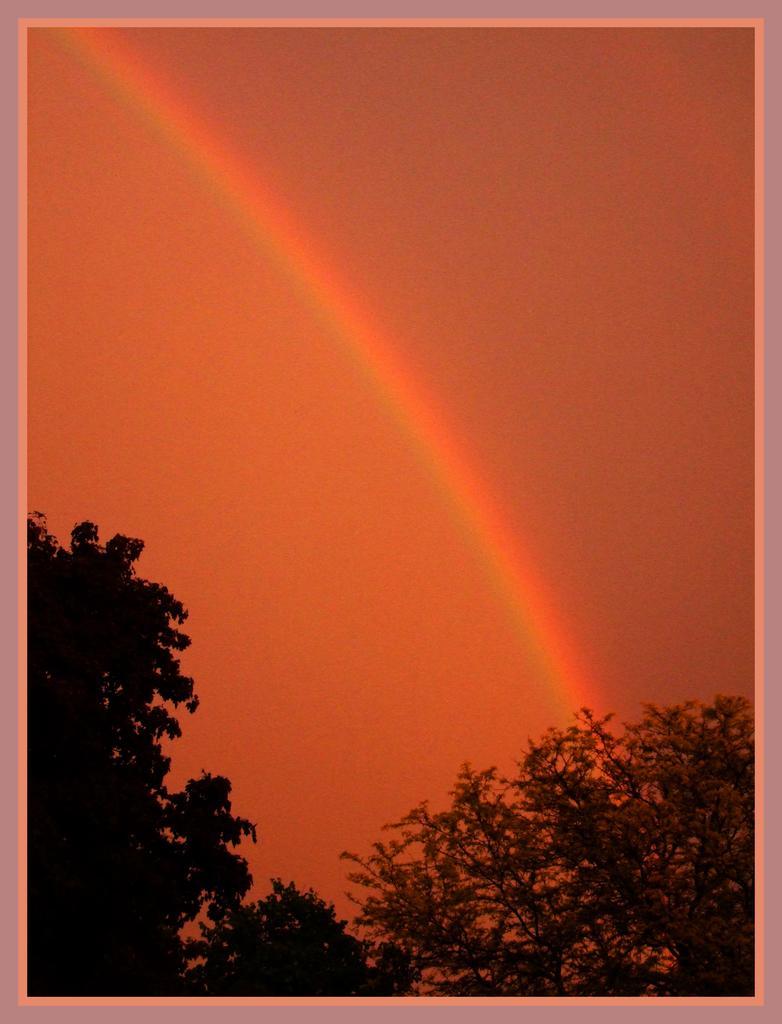Can you describe this image briefly? This picture may be consists of frame , on which there is the sky, rainbow, trees visible. 